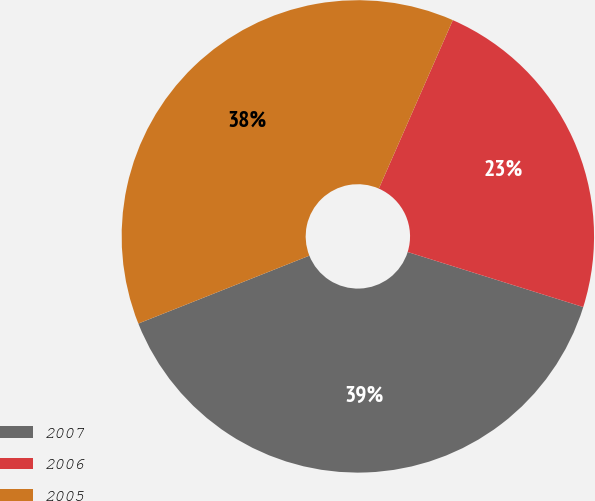Convert chart to OTSL. <chart><loc_0><loc_0><loc_500><loc_500><pie_chart><fcel>2007<fcel>2006<fcel>2005<nl><fcel>39.15%<fcel>23.25%<fcel>37.6%<nl></chart> 